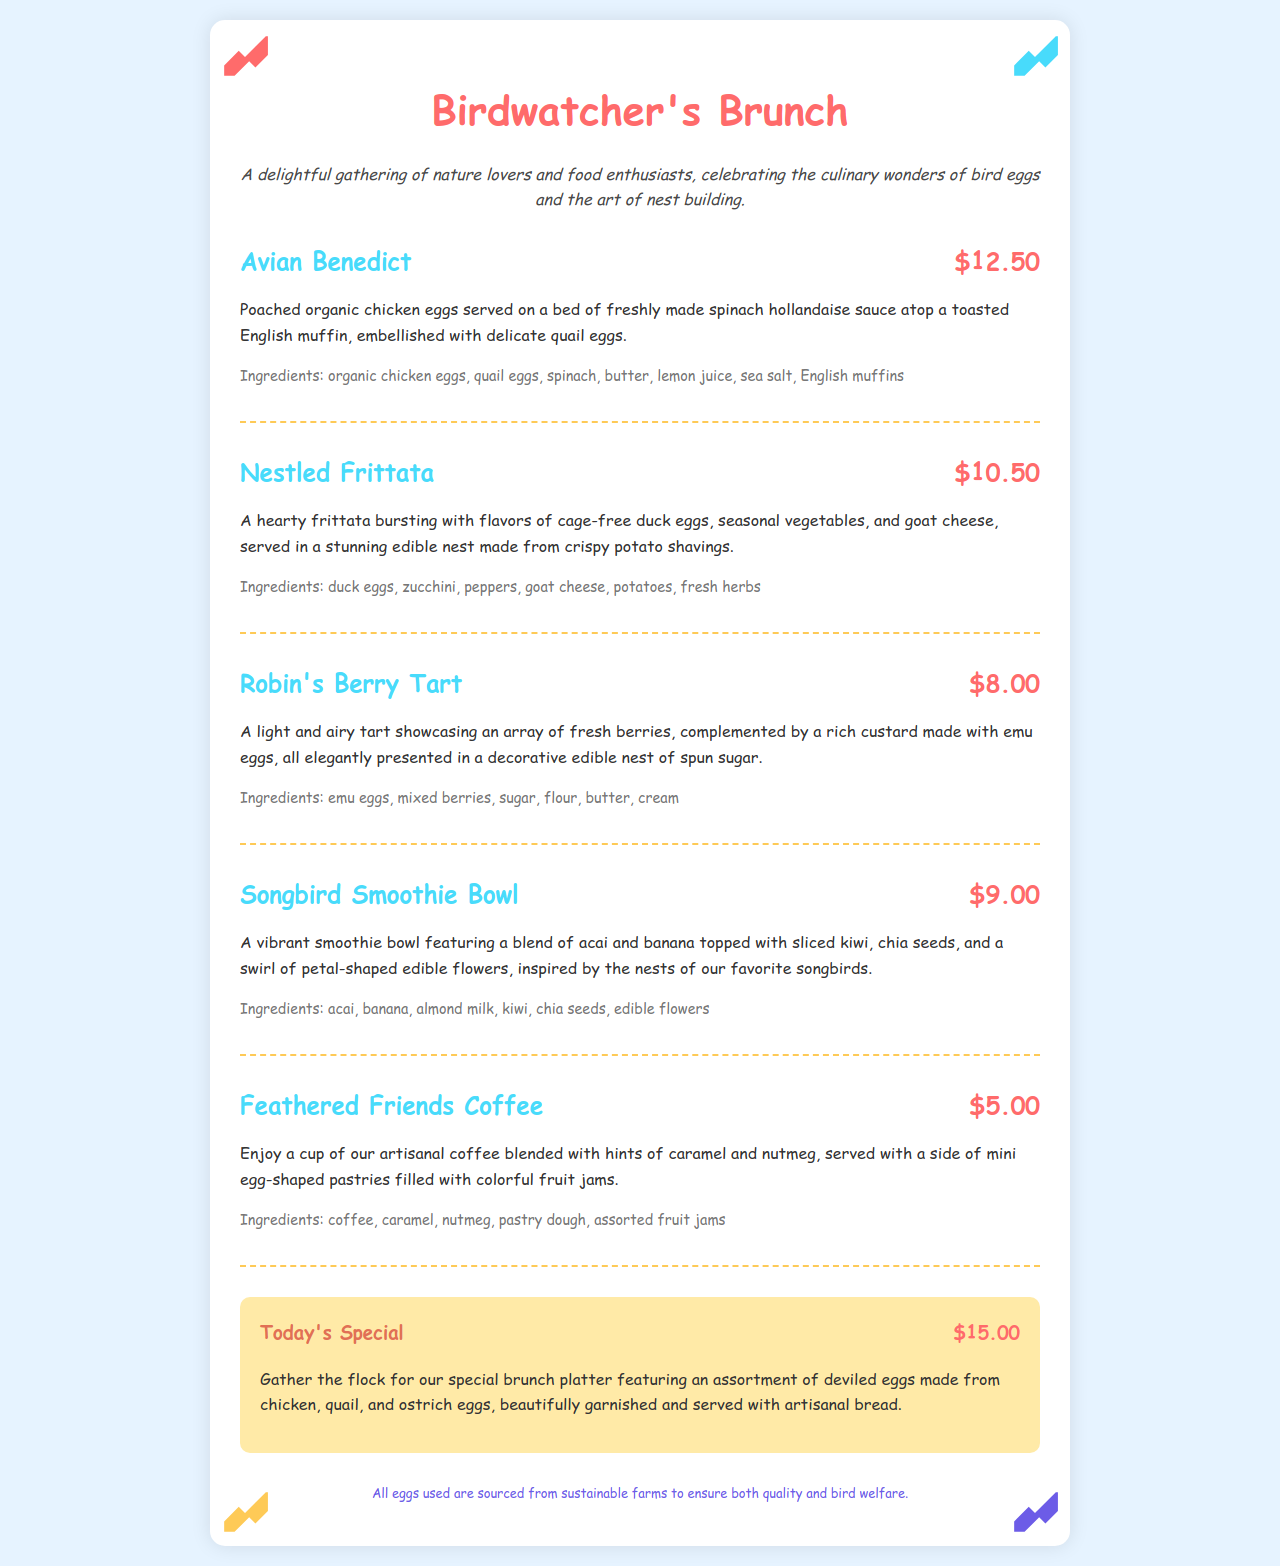What is the price of Avian Benedict? The price of Avian Benedict is stated in the menu.
Answer: $12.50 What type of eggs are used in the Robin's Berry Tart? The type of eggs used in the tart is mentioned in the ingredients section of the menu.
Answer: Emu eggs How much does the Nestled Frittata cost? The cost of the Nestled Frittata is listed next to the dish on the menu.
Answer: $10.50 What is the special dish for today? The special dish for today is described in the special section of the menu.
Answer: Deviled eggs platter Which dish features a smoothie bowl? The dish that has a smoothie bowl is mentioned in the menu item titles.
Answer: Songbird Smoothie Bowl How many types of eggs are used in the special dish? The special dish mentions multiple types of eggs, which can be counted for this answer.
Answer: Three types What is included with the Feathered Friends Coffee? The menu details what comes with the coffee.
Answer: Mini egg-shaped pastries What kind of milk is used in the Songbird Smoothie Bowl? The type of milk used in the dish is specified in the ingredients.
Answer: Almond milk What is the primary vegetable in the Nestled Frittata? The main vegetable is indicated in the ingredients list for the frittata.
Answer: Zucchini 